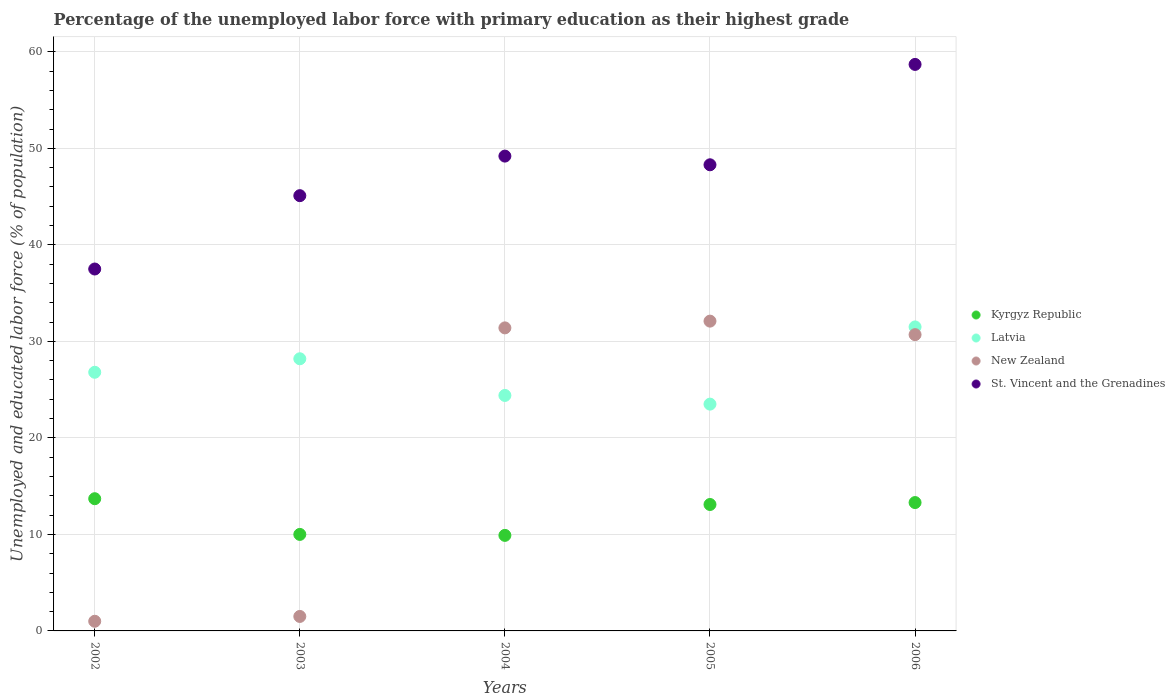How many different coloured dotlines are there?
Offer a terse response. 4. Is the number of dotlines equal to the number of legend labels?
Offer a very short reply. Yes. What is the percentage of the unemployed labor force with primary education in St. Vincent and the Grenadines in 2004?
Keep it short and to the point. 49.2. Across all years, what is the maximum percentage of the unemployed labor force with primary education in St. Vincent and the Grenadines?
Your answer should be compact. 58.7. What is the total percentage of the unemployed labor force with primary education in Latvia in the graph?
Provide a succinct answer. 134.4. What is the difference between the percentage of the unemployed labor force with primary education in New Zealand in 2003 and that in 2006?
Provide a short and direct response. -29.2. What is the difference between the percentage of the unemployed labor force with primary education in Latvia in 2006 and the percentage of the unemployed labor force with primary education in Kyrgyz Republic in 2002?
Keep it short and to the point. 17.8. What is the average percentage of the unemployed labor force with primary education in Latvia per year?
Make the answer very short. 26.88. In the year 2006, what is the difference between the percentage of the unemployed labor force with primary education in St. Vincent and the Grenadines and percentage of the unemployed labor force with primary education in New Zealand?
Offer a terse response. 28. What is the ratio of the percentage of the unemployed labor force with primary education in Latvia in 2002 to that in 2005?
Give a very brief answer. 1.14. Is the difference between the percentage of the unemployed labor force with primary education in St. Vincent and the Grenadines in 2004 and 2006 greater than the difference between the percentage of the unemployed labor force with primary education in New Zealand in 2004 and 2006?
Offer a terse response. No. What is the difference between the highest and the second highest percentage of the unemployed labor force with primary education in Latvia?
Your response must be concise. 3.3. What is the difference between the highest and the lowest percentage of the unemployed labor force with primary education in St. Vincent and the Grenadines?
Make the answer very short. 21.2. Does the percentage of the unemployed labor force with primary education in Latvia monotonically increase over the years?
Offer a terse response. No. Is the percentage of the unemployed labor force with primary education in St. Vincent and the Grenadines strictly less than the percentage of the unemployed labor force with primary education in Kyrgyz Republic over the years?
Offer a terse response. No. How many dotlines are there?
Your answer should be very brief. 4. What is the difference between two consecutive major ticks on the Y-axis?
Ensure brevity in your answer.  10. Does the graph contain any zero values?
Ensure brevity in your answer.  No. Does the graph contain grids?
Keep it short and to the point. Yes. Where does the legend appear in the graph?
Give a very brief answer. Center right. How many legend labels are there?
Your answer should be compact. 4. How are the legend labels stacked?
Your response must be concise. Vertical. What is the title of the graph?
Give a very brief answer. Percentage of the unemployed labor force with primary education as their highest grade. What is the label or title of the X-axis?
Provide a succinct answer. Years. What is the label or title of the Y-axis?
Offer a very short reply. Unemployed and educated labor force (% of population). What is the Unemployed and educated labor force (% of population) of Kyrgyz Republic in 2002?
Ensure brevity in your answer.  13.7. What is the Unemployed and educated labor force (% of population) in Latvia in 2002?
Provide a succinct answer. 26.8. What is the Unemployed and educated labor force (% of population) in New Zealand in 2002?
Provide a succinct answer. 1. What is the Unemployed and educated labor force (% of population) in St. Vincent and the Grenadines in 2002?
Your answer should be very brief. 37.5. What is the Unemployed and educated labor force (% of population) of Latvia in 2003?
Offer a very short reply. 28.2. What is the Unemployed and educated labor force (% of population) of St. Vincent and the Grenadines in 2003?
Offer a very short reply. 45.1. What is the Unemployed and educated labor force (% of population) of Kyrgyz Republic in 2004?
Your answer should be very brief. 9.9. What is the Unemployed and educated labor force (% of population) in Latvia in 2004?
Offer a terse response. 24.4. What is the Unemployed and educated labor force (% of population) of New Zealand in 2004?
Give a very brief answer. 31.4. What is the Unemployed and educated labor force (% of population) of St. Vincent and the Grenadines in 2004?
Your response must be concise. 49.2. What is the Unemployed and educated labor force (% of population) of Kyrgyz Republic in 2005?
Give a very brief answer. 13.1. What is the Unemployed and educated labor force (% of population) in New Zealand in 2005?
Provide a short and direct response. 32.1. What is the Unemployed and educated labor force (% of population) of St. Vincent and the Grenadines in 2005?
Make the answer very short. 48.3. What is the Unemployed and educated labor force (% of population) in Kyrgyz Republic in 2006?
Your response must be concise. 13.3. What is the Unemployed and educated labor force (% of population) of Latvia in 2006?
Your answer should be very brief. 31.5. What is the Unemployed and educated labor force (% of population) of New Zealand in 2006?
Your answer should be compact. 30.7. What is the Unemployed and educated labor force (% of population) of St. Vincent and the Grenadines in 2006?
Ensure brevity in your answer.  58.7. Across all years, what is the maximum Unemployed and educated labor force (% of population) in Kyrgyz Republic?
Give a very brief answer. 13.7. Across all years, what is the maximum Unemployed and educated labor force (% of population) in Latvia?
Your answer should be very brief. 31.5. Across all years, what is the maximum Unemployed and educated labor force (% of population) in New Zealand?
Your answer should be compact. 32.1. Across all years, what is the maximum Unemployed and educated labor force (% of population) of St. Vincent and the Grenadines?
Offer a terse response. 58.7. Across all years, what is the minimum Unemployed and educated labor force (% of population) of Kyrgyz Republic?
Ensure brevity in your answer.  9.9. Across all years, what is the minimum Unemployed and educated labor force (% of population) in Latvia?
Your answer should be compact. 23.5. Across all years, what is the minimum Unemployed and educated labor force (% of population) of New Zealand?
Give a very brief answer. 1. Across all years, what is the minimum Unemployed and educated labor force (% of population) of St. Vincent and the Grenadines?
Make the answer very short. 37.5. What is the total Unemployed and educated labor force (% of population) in Kyrgyz Republic in the graph?
Give a very brief answer. 60. What is the total Unemployed and educated labor force (% of population) of Latvia in the graph?
Make the answer very short. 134.4. What is the total Unemployed and educated labor force (% of population) of New Zealand in the graph?
Provide a succinct answer. 96.7. What is the total Unemployed and educated labor force (% of population) in St. Vincent and the Grenadines in the graph?
Keep it short and to the point. 238.8. What is the difference between the Unemployed and educated labor force (% of population) in Latvia in 2002 and that in 2003?
Your answer should be compact. -1.4. What is the difference between the Unemployed and educated labor force (% of population) of St. Vincent and the Grenadines in 2002 and that in 2003?
Provide a short and direct response. -7.6. What is the difference between the Unemployed and educated labor force (% of population) in Kyrgyz Republic in 2002 and that in 2004?
Your answer should be compact. 3.8. What is the difference between the Unemployed and educated labor force (% of population) of New Zealand in 2002 and that in 2004?
Keep it short and to the point. -30.4. What is the difference between the Unemployed and educated labor force (% of population) in St. Vincent and the Grenadines in 2002 and that in 2004?
Ensure brevity in your answer.  -11.7. What is the difference between the Unemployed and educated labor force (% of population) in Latvia in 2002 and that in 2005?
Give a very brief answer. 3.3. What is the difference between the Unemployed and educated labor force (% of population) in New Zealand in 2002 and that in 2005?
Provide a succinct answer. -31.1. What is the difference between the Unemployed and educated labor force (% of population) of St. Vincent and the Grenadines in 2002 and that in 2005?
Provide a short and direct response. -10.8. What is the difference between the Unemployed and educated labor force (% of population) of Latvia in 2002 and that in 2006?
Ensure brevity in your answer.  -4.7. What is the difference between the Unemployed and educated labor force (% of population) of New Zealand in 2002 and that in 2006?
Your answer should be compact. -29.7. What is the difference between the Unemployed and educated labor force (% of population) of St. Vincent and the Grenadines in 2002 and that in 2006?
Offer a terse response. -21.2. What is the difference between the Unemployed and educated labor force (% of population) of Latvia in 2003 and that in 2004?
Offer a terse response. 3.8. What is the difference between the Unemployed and educated labor force (% of population) in New Zealand in 2003 and that in 2004?
Make the answer very short. -29.9. What is the difference between the Unemployed and educated labor force (% of population) in Latvia in 2003 and that in 2005?
Ensure brevity in your answer.  4.7. What is the difference between the Unemployed and educated labor force (% of population) of New Zealand in 2003 and that in 2005?
Offer a terse response. -30.6. What is the difference between the Unemployed and educated labor force (% of population) in New Zealand in 2003 and that in 2006?
Provide a short and direct response. -29.2. What is the difference between the Unemployed and educated labor force (% of population) in St. Vincent and the Grenadines in 2003 and that in 2006?
Your answer should be compact. -13.6. What is the difference between the Unemployed and educated labor force (% of population) of Kyrgyz Republic in 2004 and that in 2006?
Give a very brief answer. -3.4. What is the difference between the Unemployed and educated labor force (% of population) of New Zealand in 2004 and that in 2006?
Provide a succinct answer. 0.7. What is the difference between the Unemployed and educated labor force (% of population) of St. Vincent and the Grenadines in 2004 and that in 2006?
Your response must be concise. -9.5. What is the difference between the Unemployed and educated labor force (% of population) in New Zealand in 2005 and that in 2006?
Your response must be concise. 1.4. What is the difference between the Unemployed and educated labor force (% of population) in Kyrgyz Republic in 2002 and the Unemployed and educated labor force (% of population) in St. Vincent and the Grenadines in 2003?
Your answer should be very brief. -31.4. What is the difference between the Unemployed and educated labor force (% of population) of Latvia in 2002 and the Unemployed and educated labor force (% of population) of New Zealand in 2003?
Provide a short and direct response. 25.3. What is the difference between the Unemployed and educated labor force (% of population) of Latvia in 2002 and the Unemployed and educated labor force (% of population) of St. Vincent and the Grenadines in 2003?
Ensure brevity in your answer.  -18.3. What is the difference between the Unemployed and educated labor force (% of population) of New Zealand in 2002 and the Unemployed and educated labor force (% of population) of St. Vincent and the Grenadines in 2003?
Give a very brief answer. -44.1. What is the difference between the Unemployed and educated labor force (% of population) of Kyrgyz Republic in 2002 and the Unemployed and educated labor force (% of population) of Latvia in 2004?
Your answer should be very brief. -10.7. What is the difference between the Unemployed and educated labor force (% of population) of Kyrgyz Republic in 2002 and the Unemployed and educated labor force (% of population) of New Zealand in 2004?
Ensure brevity in your answer.  -17.7. What is the difference between the Unemployed and educated labor force (% of population) in Kyrgyz Republic in 2002 and the Unemployed and educated labor force (% of population) in St. Vincent and the Grenadines in 2004?
Offer a very short reply. -35.5. What is the difference between the Unemployed and educated labor force (% of population) of Latvia in 2002 and the Unemployed and educated labor force (% of population) of New Zealand in 2004?
Keep it short and to the point. -4.6. What is the difference between the Unemployed and educated labor force (% of population) of Latvia in 2002 and the Unemployed and educated labor force (% of population) of St. Vincent and the Grenadines in 2004?
Offer a very short reply. -22.4. What is the difference between the Unemployed and educated labor force (% of population) of New Zealand in 2002 and the Unemployed and educated labor force (% of population) of St. Vincent and the Grenadines in 2004?
Your response must be concise. -48.2. What is the difference between the Unemployed and educated labor force (% of population) in Kyrgyz Republic in 2002 and the Unemployed and educated labor force (% of population) in Latvia in 2005?
Give a very brief answer. -9.8. What is the difference between the Unemployed and educated labor force (% of population) in Kyrgyz Republic in 2002 and the Unemployed and educated labor force (% of population) in New Zealand in 2005?
Your answer should be compact. -18.4. What is the difference between the Unemployed and educated labor force (% of population) in Kyrgyz Republic in 2002 and the Unemployed and educated labor force (% of population) in St. Vincent and the Grenadines in 2005?
Provide a succinct answer. -34.6. What is the difference between the Unemployed and educated labor force (% of population) of Latvia in 2002 and the Unemployed and educated labor force (% of population) of St. Vincent and the Grenadines in 2005?
Provide a succinct answer. -21.5. What is the difference between the Unemployed and educated labor force (% of population) in New Zealand in 2002 and the Unemployed and educated labor force (% of population) in St. Vincent and the Grenadines in 2005?
Give a very brief answer. -47.3. What is the difference between the Unemployed and educated labor force (% of population) in Kyrgyz Republic in 2002 and the Unemployed and educated labor force (% of population) in Latvia in 2006?
Keep it short and to the point. -17.8. What is the difference between the Unemployed and educated labor force (% of population) of Kyrgyz Republic in 2002 and the Unemployed and educated labor force (% of population) of New Zealand in 2006?
Your answer should be compact. -17. What is the difference between the Unemployed and educated labor force (% of population) in Kyrgyz Republic in 2002 and the Unemployed and educated labor force (% of population) in St. Vincent and the Grenadines in 2006?
Offer a terse response. -45. What is the difference between the Unemployed and educated labor force (% of population) of Latvia in 2002 and the Unemployed and educated labor force (% of population) of St. Vincent and the Grenadines in 2006?
Your answer should be very brief. -31.9. What is the difference between the Unemployed and educated labor force (% of population) of New Zealand in 2002 and the Unemployed and educated labor force (% of population) of St. Vincent and the Grenadines in 2006?
Your answer should be compact. -57.7. What is the difference between the Unemployed and educated labor force (% of population) in Kyrgyz Republic in 2003 and the Unemployed and educated labor force (% of population) in Latvia in 2004?
Your answer should be very brief. -14.4. What is the difference between the Unemployed and educated labor force (% of population) of Kyrgyz Republic in 2003 and the Unemployed and educated labor force (% of population) of New Zealand in 2004?
Your response must be concise. -21.4. What is the difference between the Unemployed and educated labor force (% of population) of Kyrgyz Republic in 2003 and the Unemployed and educated labor force (% of population) of St. Vincent and the Grenadines in 2004?
Keep it short and to the point. -39.2. What is the difference between the Unemployed and educated labor force (% of population) of Latvia in 2003 and the Unemployed and educated labor force (% of population) of St. Vincent and the Grenadines in 2004?
Your answer should be very brief. -21. What is the difference between the Unemployed and educated labor force (% of population) of New Zealand in 2003 and the Unemployed and educated labor force (% of population) of St. Vincent and the Grenadines in 2004?
Make the answer very short. -47.7. What is the difference between the Unemployed and educated labor force (% of population) in Kyrgyz Republic in 2003 and the Unemployed and educated labor force (% of population) in Latvia in 2005?
Your response must be concise. -13.5. What is the difference between the Unemployed and educated labor force (% of population) in Kyrgyz Republic in 2003 and the Unemployed and educated labor force (% of population) in New Zealand in 2005?
Your answer should be very brief. -22.1. What is the difference between the Unemployed and educated labor force (% of population) in Kyrgyz Republic in 2003 and the Unemployed and educated labor force (% of population) in St. Vincent and the Grenadines in 2005?
Your answer should be compact. -38.3. What is the difference between the Unemployed and educated labor force (% of population) of Latvia in 2003 and the Unemployed and educated labor force (% of population) of New Zealand in 2005?
Your response must be concise. -3.9. What is the difference between the Unemployed and educated labor force (% of population) in Latvia in 2003 and the Unemployed and educated labor force (% of population) in St. Vincent and the Grenadines in 2005?
Make the answer very short. -20.1. What is the difference between the Unemployed and educated labor force (% of population) in New Zealand in 2003 and the Unemployed and educated labor force (% of population) in St. Vincent and the Grenadines in 2005?
Provide a short and direct response. -46.8. What is the difference between the Unemployed and educated labor force (% of population) of Kyrgyz Republic in 2003 and the Unemployed and educated labor force (% of population) of Latvia in 2006?
Your answer should be very brief. -21.5. What is the difference between the Unemployed and educated labor force (% of population) in Kyrgyz Republic in 2003 and the Unemployed and educated labor force (% of population) in New Zealand in 2006?
Make the answer very short. -20.7. What is the difference between the Unemployed and educated labor force (% of population) of Kyrgyz Republic in 2003 and the Unemployed and educated labor force (% of population) of St. Vincent and the Grenadines in 2006?
Provide a succinct answer. -48.7. What is the difference between the Unemployed and educated labor force (% of population) in Latvia in 2003 and the Unemployed and educated labor force (% of population) in St. Vincent and the Grenadines in 2006?
Give a very brief answer. -30.5. What is the difference between the Unemployed and educated labor force (% of population) of New Zealand in 2003 and the Unemployed and educated labor force (% of population) of St. Vincent and the Grenadines in 2006?
Offer a very short reply. -57.2. What is the difference between the Unemployed and educated labor force (% of population) in Kyrgyz Republic in 2004 and the Unemployed and educated labor force (% of population) in Latvia in 2005?
Your response must be concise. -13.6. What is the difference between the Unemployed and educated labor force (% of population) of Kyrgyz Republic in 2004 and the Unemployed and educated labor force (% of population) of New Zealand in 2005?
Your answer should be very brief. -22.2. What is the difference between the Unemployed and educated labor force (% of population) of Kyrgyz Republic in 2004 and the Unemployed and educated labor force (% of population) of St. Vincent and the Grenadines in 2005?
Offer a very short reply. -38.4. What is the difference between the Unemployed and educated labor force (% of population) of Latvia in 2004 and the Unemployed and educated labor force (% of population) of New Zealand in 2005?
Ensure brevity in your answer.  -7.7. What is the difference between the Unemployed and educated labor force (% of population) in Latvia in 2004 and the Unemployed and educated labor force (% of population) in St. Vincent and the Grenadines in 2005?
Make the answer very short. -23.9. What is the difference between the Unemployed and educated labor force (% of population) of New Zealand in 2004 and the Unemployed and educated labor force (% of population) of St. Vincent and the Grenadines in 2005?
Provide a succinct answer. -16.9. What is the difference between the Unemployed and educated labor force (% of population) of Kyrgyz Republic in 2004 and the Unemployed and educated labor force (% of population) of Latvia in 2006?
Give a very brief answer. -21.6. What is the difference between the Unemployed and educated labor force (% of population) of Kyrgyz Republic in 2004 and the Unemployed and educated labor force (% of population) of New Zealand in 2006?
Your answer should be very brief. -20.8. What is the difference between the Unemployed and educated labor force (% of population) of Kyrgyz Republic in 2004 and the Unemployed and educated labor force (% of population) of St. Vincent and the Grenadines in 2006?
Make the answer very short. -48.8. What is the difference between the Unemployed and educated labor force (% of population) in Latvia in 2004 and the Unemployed and educated labor force (% of population) in New Zealand in 2006?
Provide a short and direct response. -6.3. What is the difference between the Unemployed and educated labor force (% of population) of Latvia in 2004 and the Unemployed and educated labor force (% of population) of St. Vincent and the Grenadines in 2006?
Offer a terse response. -34.3. What is the difference between the Unemployed and educated labor force (% of population) of New Zealand in 2004 and the Unemployed and educated labor force (% of population) of St. Vincent and the Grenadines in 2006?
Provide a succinct answer. -27.3. What is the difference between the Unemployed and educated labor force (% of population) of Kyrgyz Republic in 2005 and the Unemployed and educated labor force (% of population) of Latvia in 2006?
Your response must be concise. -18.4. What is the difference between the Unemployed and educated labor force (% of population) of Kyrgyz Republic in 2005 and the Unemployed and educated labor force (% of population) of New Zealand in 2006?
Ensure brevity in your answer.  -17.6. What is the difference between the Unemployed and educated labor force (% of population) in Kyrgyz Republic in 2005 and the Unemployed and educated labor force (% of population) in St. Vincent and the Grenadines in 2006?
Your answer should be compact. -45.6. What is the difference between the Unemployed and educated labor force (% of population) of Latvia in 2005 and the Unemployed and educated labor force (% of population) of St. Vincent and the Grenadines in 2006?
Offer a terse response. -35.2. What is the difference between the Unemployed and educated labor force (% of population) in New Zealand in 2005 and the Unemployed and educated labor force (% of population) in St. Vincent and the Grenadines in 2006?
Give a very brief answer. -26.6. What is the average Unemployed and educated labor force (% of population) in Kyrgyz Republic per year?
Your answer should be very brief. 12. What is the average Unemployed and educated labor force (% of population) in Latvia per year?
Your answer should be very brief. 26.88. What is the average Unemployed and educated labor force (% of population) of New Zealand per year?
Offer a very short reply. 19.34. What is the average Unemployed and educated labor force (% of population) in St. Vincent and the Grenadines per year?
Offer a terse response. 47.76. In the year 2002, what is the difference between the Unemployed and educated labor force (% of population) in Kyrgyz Republic and Unemployed and educated labor force (% of population) in Latvia?
Make the answer very short. -13.1. In the year 2002, what is the difference between the Unemployed and educated labor force (% of population) of Kyrgyz Republic and Unemployed and educated labor force (% of population) of St. Vincent and the Grenadines?
Your response must be concise. -23.8. In the year 2002, what is the difference between the Unemployed and educated labor force (% of population) of Latvia and Unemployed and educated labor force (% of population) of New Zealand?
Keep it short and to the point. 25.8. In the year 2002, what is the difference between the Unemployed and educated labor force (% of population) in New Zealand and Unemployed and educated labor force (% of population) in St. Vincent and the Grenadines?
Offer a very short reply. -36.5. In the year 2003, what is the difference between the Unemployed and educated labor force (% of population) in Kyrgyz Republic and Unemployed and educated labor force (% of population) in Latvia?
Offer a very short reply. -18.2. In the year 2003, what is the difference between the Unemployed and educated labor force (% of population) of Kyrgyz Republic and Unemployed and educated labor force (% of population) of St. Vincent and the Grenadines?
Offer a very short reply. -35.1. In the year 2003, what is the difference between the Unemployed and educated labor force (% of population) of Latvia and Unemployed and educated labor force (% of population) of New Zealand?
Provide a short and direct response. 26.7. In the year 2003, what is the difference between the Unemployed and educated labor force (% of population) of Latvia and Unemployed and educated labor force (% of population) of St. Vincent and the Grenadines?
Your answer should be very brief. -16.9. In the year 2003, what is the difference between the Unemployed and educated labor force (% of population) in New Zealand and Unemployed and educated labor force (% of population) in St. Vincent and the Grenadines?
Provide a short and direct response. -43.6. In the year 2004, what is the difference between the Unemployed and educated labor force (% of population) of Kyrgyz Republic and Unemployed and educated labor force (% of population) of Latvia?
Your response must be concise. -14.5. In the year 2004, what is the difference between the Unemployed and educated labor force (% of population) in Kyrgyz Republic and Unemployed and educated labor force (% of population) in New Zealand?
Keep it short and to the point. -21.5. In the year 2004, what is the difference between the Unemployed and educated labor force (% of population) of Kyrgyz Republic and Unemployed and educated labor force (% of population) of St. Vincent and the Grenadines?
Keep it short and to the point. -39.3. In the year 2004, what is the difference between the Unemployed and educated labor force (% of population) in Latvia and Unemployed and educated labor force (% of population) in New Zealand?
Your response must be concise. -7. In the year 2004, what is the difference between the Unemployed and educated labor force (% of population) in Latvia and Unemployed and educated labor force (% of population) in St. Vincent and the Grenadines?
Give a very brief answer. -24.8. In the year 2004, what is the difference between the Unemployed and educated labor force (% of population) of New Zealand and Unemployed and educated labor force (% of population) of St. Vincent and the Grenadines?
Offer a very short reply. -17.8. In the year 2005, what is the difference between the Unemployed and educated labor force (% of population) in Kyrgyz Republic and Unemployed and educated labor force (% of population) in St. Vincent and the Grenadines?
Ensure brevity in your answer.  -35.2. In the year 2005, what is the difference between the Unemployed and educated labor force (% of population) of Latvia and Unemployed and educated labor force (% of population) of New Zealand?
Your response must be concise. -8.6. In the year 2005, what is the difference between the Unemployed and educated labor force (% of population) in Latvia and Unemployed and educated labor force (% of population) in St. Vincent and the Grenadines?
Keep it short and to the point. -24.8. In the year 2005, what is the difference between the Unemployed and educated labor force (% of population) in New Zealand and Unemployed and educated labor force (% of population) in St. Vincent and the Grenadines?
Provide a succinct answer. -16.2. In the year 2006, what is the difference between the Unemployed and educated labor force (% of population) in Kyrgyz Republic and Unemployed and educated labor force (% of population) in Latvia?
Ensure brevity in your answer.  -18.2. In the year 2006, what is the difference between the Unemployed and educated labor force (% of population) of Kyrgyz Republic and Unemployed and educated labor force (% of population) of New Zealand?
Provide a short and direct response. -17.4. In the year 2006, what is the difference between the Unemployed and educated labor force (% of population) in Kyrgyz Republic and Unemployed and educated labor force (% of population) in St. Vincent and the Grenadines?
Your answer should be compact. -45.4. In the year 2006, what is the difference between the Unemployed and educated labor force (% of population) of Latvia and Unemployed and educated labor force (% of population) of New Zealand?
Ensure brevity in your answer.  0.8. In the year 2006, what is the difference between the Unemployed and educated labor force (% of population) of Latvia and Unemployed and educated labor force (% of population) of St. Vincent and the Grenadines?
Offer a terse response. -27.2. In the year 2006, what is the difference between the Unemployed and educated labor force (% of population) of New Zealand and Unemployed and educated labor force (% of population) of St. Vincent and the Grenadines?
Make the answer very short. -28. What is the ratio of the Unemployed and educated labor force (% of population) of Kyrgyz Republic in 2002 to that in 2003?
Provide a succinct answer. 1.37. What is the ratio of the Unemployed and educated labor force (% of population) in Latvia in 2002 to that in 2003?
Give a very brief answer. 0.95. What is the ratio of the Unemployed and educated labor force (% of population) in St. Vincent and the Grenadines in 2002 to that in 2003?
Offer a very short reply. 0.83. What is the ratio of the Unemployed and educated labor force (% of population) in Kyrgyz Republic in 2002 to that in 2004?
Keep it short and to the point. 1.38. What is the ratio of the Unemployed and educated labor force (% of population) in Latvia in 2002 to that in 2004?
Offer a terse response. 1.1. What is the ratio of the Unemployed and educated labor force (% of population) in New Zealand in 2002 to that in 2004?
Make the answer very short. 0.03. What is the ratio of the Unemployed and educated labor force (% of population) in St. Vincent and the Grenadines in 2002 to that in 2004?
Your response must be concise. 0.76. What is the ratio of the Unemployed and educated labor force (% of population) in Kyrgyz Republic in 2002 to that in 2005?
Provide a short and direct response. 1.05. What is the ratio of the Unemployed and educated labor force (% of population) in Latvia in 2002 to that in 2005?
Ensure brevity in your answer.  1.14. What is the ratio of the Unemployed and educated labor force (% of population) in New Zealand in 2002 to that in 2005?
Your answer should be very brief. 0.03. What is the ratio of the Unemployed and educated labor force (% of population) of St. Vincent and the Grenadines in 2002 to that in 2005?
Your response must be concise. 0.78. What is the ratio of the Unemployed and educated labor force (% of population) of Kyrgyz Republic in 2002 to that in 2006?
Keep it short and to the point. 1.03. What is the ratio of the Unemployed and educated labor force (% of population) in Latvia in 2002 to that in 2006?
Your answer should be very brief. 0.85. What is the ratio of the Unemployed and educated labor force (% of population) of New Zealand in 2002 to that in 2006?
Ensure brevity in your answer.  0.03. What is the ratio of the Unemployed and educated labor force (% of population) of St. Vincent and the Grenadines in 2002 to that in 2006?
Your response must be concise. 0.64. What is the ratio of the Unemployed and educated labor force (% of population) in Kyrgyz Republic in 2003 to that in 2004?
Your response must be concise. 1.01. What is the ratio of the Unemployed and educated labor force (% of population) of Latvia in 2003 to that in 2004?
Keep it short and to the point. 1.16. What is the ratio of the Unemployed and educated labor force (% of population) in New Zealand in 2003 to that in 2004?
Your answer should be very brief. 0.05. What is the ratio of the Unemployed and educated labor force (% of population) of Kyrgyz Republic in 2003 to that in 2005?
Your answer should be compact. 0.76. What is the ratio of the Unemployed and educated labor force (% of population) of Latvia in 2003 to that in 2005?
Provide a short and direct response. 1.2. What is the ratio of the Unemployed and educated labor force (% of population) in New Zealand in 2003 to that in 2005?
Provide a succinct answer. 0.05. What is the ratio of the Unemployed and educated labor force (% of population) in St. Vincent and the Grenadines in 2003 to that in 2005?
Offer a very short reply. 0.93. What is the ratio of the Unemployed and educated labor force (% of population) of Kyrgyz Republic in 2003 to that in 2006?
Offer a very short reply. 0.75. What is the ratio of the Unemployed and educated labor force (% of population) in Latvia in 2003 to that in 2006?
Your answer should be very brief. 0.9. What is the ratio of the Unemployed and educated labor force (% of population) in New Zealand in 2003 to that in 2006?
Make the answer very short. 0.05. What is the ratio of the Unemployed and educated labor force (% of population) in St. Vincent and the Grenadines in 2003 to that in 2006?
Ensure brevity in your answer.  0.77. What is the ratio of the Unemployed and educated labor force (% of population) in Kyrgyz Republic in 2004 to that in 2005?
Provide a short and direct response. 0.76. What is the ratio of the Unemployed and educated labor force (% of population) of Latvia in 2004 to that in 2005?
Ensure brevity in your answer.  1.04. What is the ratio of the Unemployed and educated labor force (% of population) of New Zealand in 2004 to that in 2005?
Give a very brief answer. 0.98. What is the ratio of the Unemployed and educated labor force (% of population) in St. Vincent and the Grenadines in 2004 to that in 2005?
Keep it short and to the point. 1.02. What is the ratio of the Unemployed and educated labor force (% of population) of Kyrgyz Republic in 2004 to that in 2006?
Give a very brief answer. 0.74. What is the ratio of the Unemployed and educated labor force (% of population) in Latvia in 2004 to that in 2006?
Provide a short and direct response. 0.77. What is the ratio of the Unemployed and educated labor force (% of population) in New Zealand in 2004 to that in 2006?
Give a very brief answer. 1.02. What is the ratio of the Unemployed and educated labor force (% of population) of St. Vincent and the Grenadines in 2004 to that in 2006?
Make the answer very short. 0.84. What is the ratio of the Unemployed and educated labor force (% of population) of Latvia in 2005 to that in 2006?
Offer a terse response. 0.75. What is the ratio of the Unemployed and educated labor force (% of population) of New Zealand in 2005 to that in 2006?
Provide a short and direct response. 1.05. What is the ratio of the Unemployed and educated labor force (% of population) of St. Vincent and the Grenadines in 2005 to that in 2006?
Your answer should be very brief. 0.82. What is the difference between the highest and the second highest Unemployed and educated labor force (% of population) of St. Vincent and the Grenadines?
Offer a very short reply. 9.5. What is the difference between the highest and the lowest Unemployed and educated labor force (% of population) of Kyrgyz Republic?
Your answer should be very brief. 3.8. What is the difference between the highest and the lowest Unemployed and educated labor force (% of population) of New Zealand?
Your answer should be compact. 31.1. What is the difference between the highest and the lowest Unemployed and educated labor force (% of population) of St. Vincent and the Grenadines?
Give a very brief answer. 21.2. 